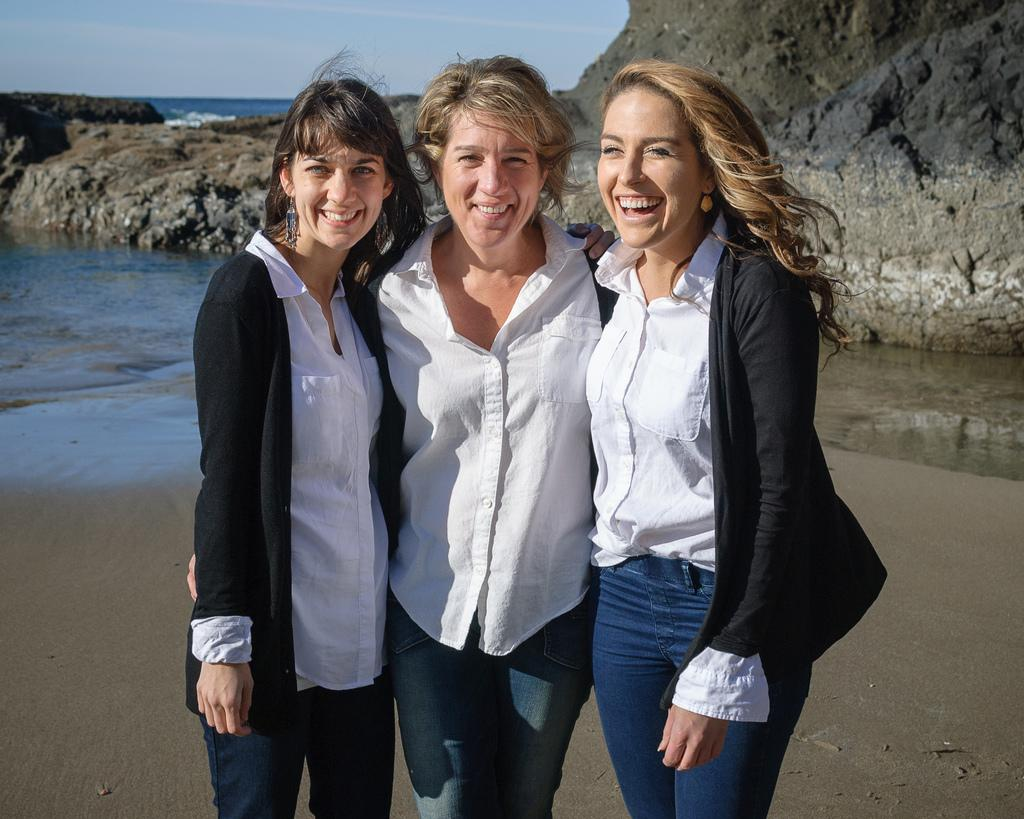How many women are in the image? There are three women in the image. What expression do the women have? The women are smiling. What can be seen in the background of the image? There is water, a rock, and the sky visible in the background of the image. What type of leaf is being processed by the thread in the image? There is no leaf or thread present in the image. 